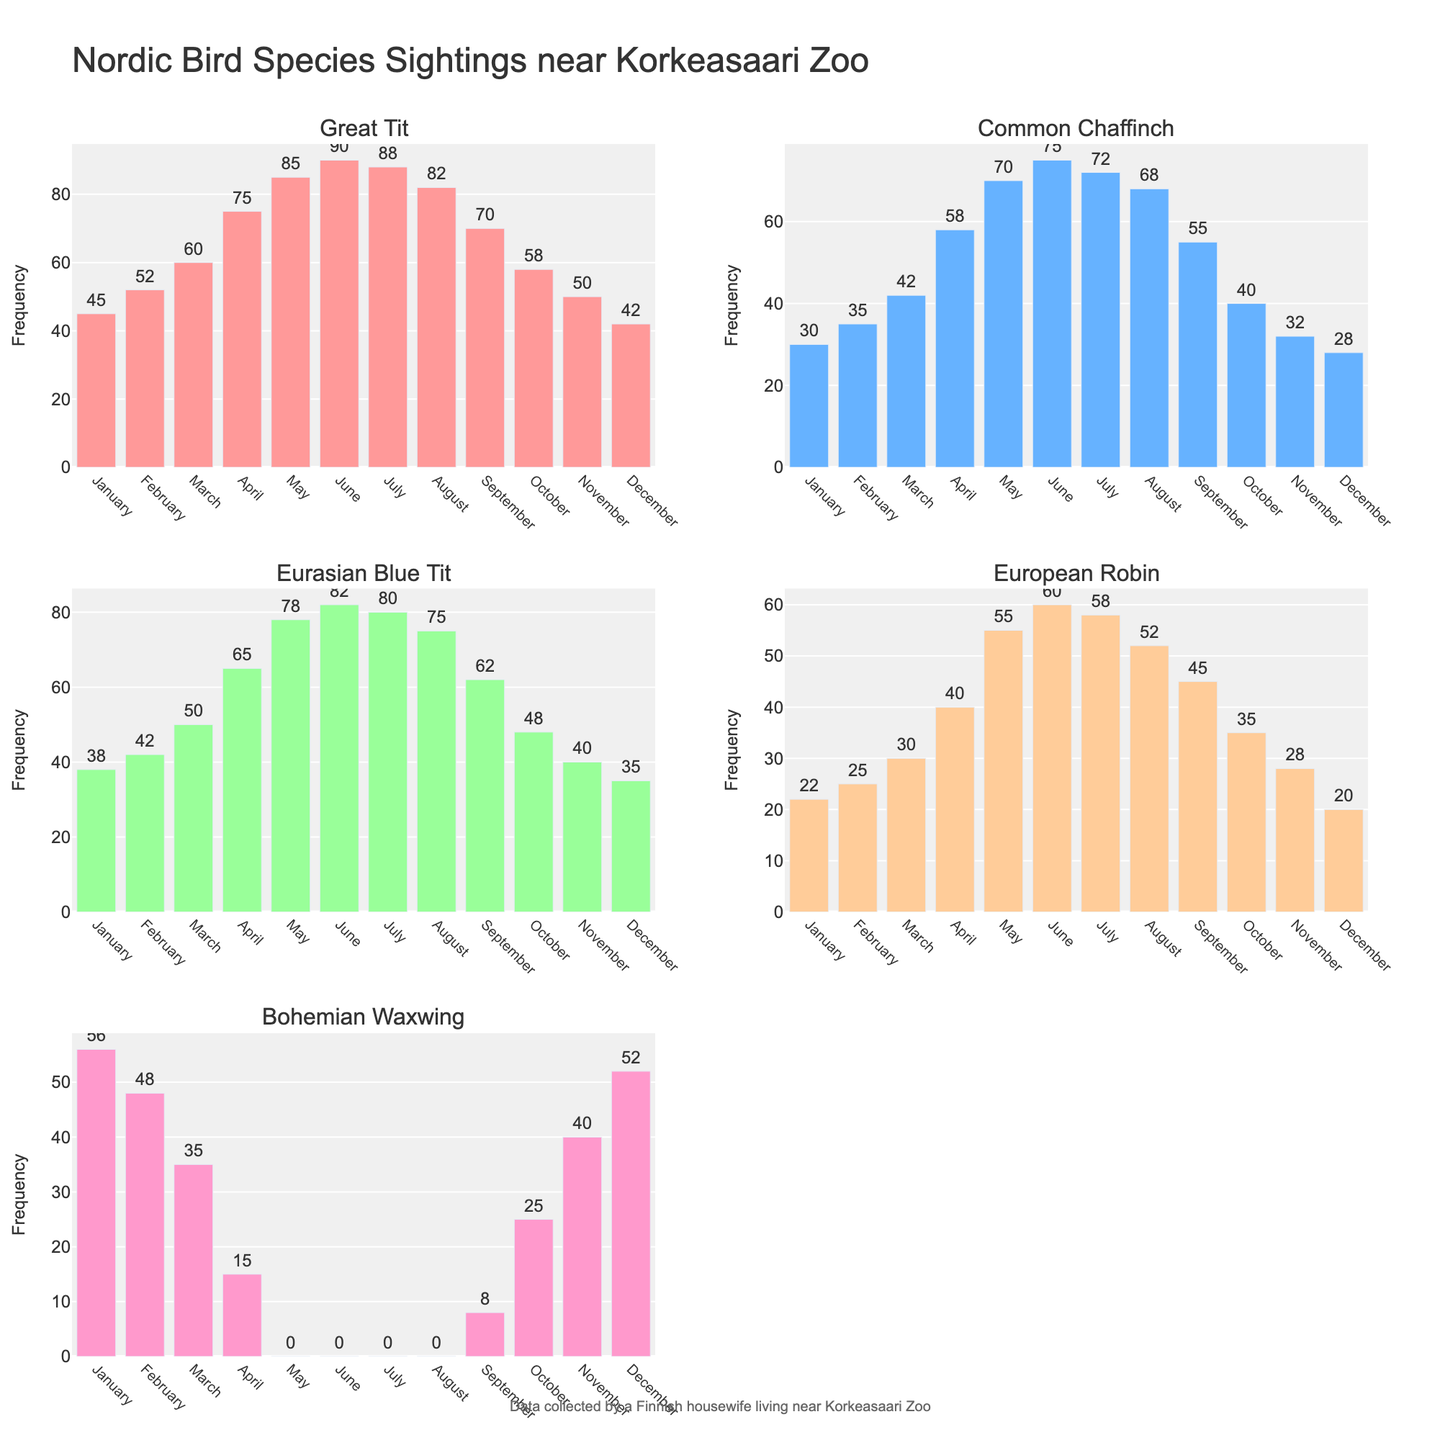What's the frequency of the Bohemian Waxwing in March? The Bohemian Waxwing has a frequency of 35 in March according to the subplot for that species.
Answer: 35 Which month has the highest frequency for the Great Tit? The highest frequency for the Great Tit is in June with a value of 90, as shown by the highest bar in its subplot.
Answer: June Is the frequency of the European Robin in December greater than in November? In the subplot for the European Robin, the frequency is 20 in December and 28 in November, so it is not greater.
Answer: No What is the total frequency of the Common Chaffinch in the first quarter of the year (January, February, March)? Summing the monthly frequencies for January (30), February (35), and March (42) gives the total frequency: 30 + 35 + 42 = 107.
Answer: 107 Does the Eurasian Blue Tit have a higher average frequency in the spring months (March, April, May) compared to the autumn months (September, October, November)? For spring (March: 50, April: 65, May: 78), the average is (50 + 65 + 78) / 3 = 64.33. For autumn (September: 62, October: 48, November: 40), the average is (62 + 48 + 40) / 3 = 50. The spring average is higher.
Answer: Yes Compare the frequency of the European Robin in the warmest month (July) and the coldest month (January). In the subplot for the European Robin, July shows a frequency of 58 and January shows a frequency of 22. July has the higher frequency.
Answer: July How many bird species have zero frequency in May? According to their respective subplots, only the Bohemian Waxwing shows zero frequency in May.
Answer: 1 What is the trend of Bohemian Waxwing sightings from October to December? In its subplot, the frequencies are 25 (October), 40 (November), and 52 (December), showing a clear increasing trend.
Answer: Increasing Which bird species shows the most consistent frequency throughout the year? By observing all subplots, the Great Tit shows relatively consistent values without large fluctuations.
Answer: Great Tit 